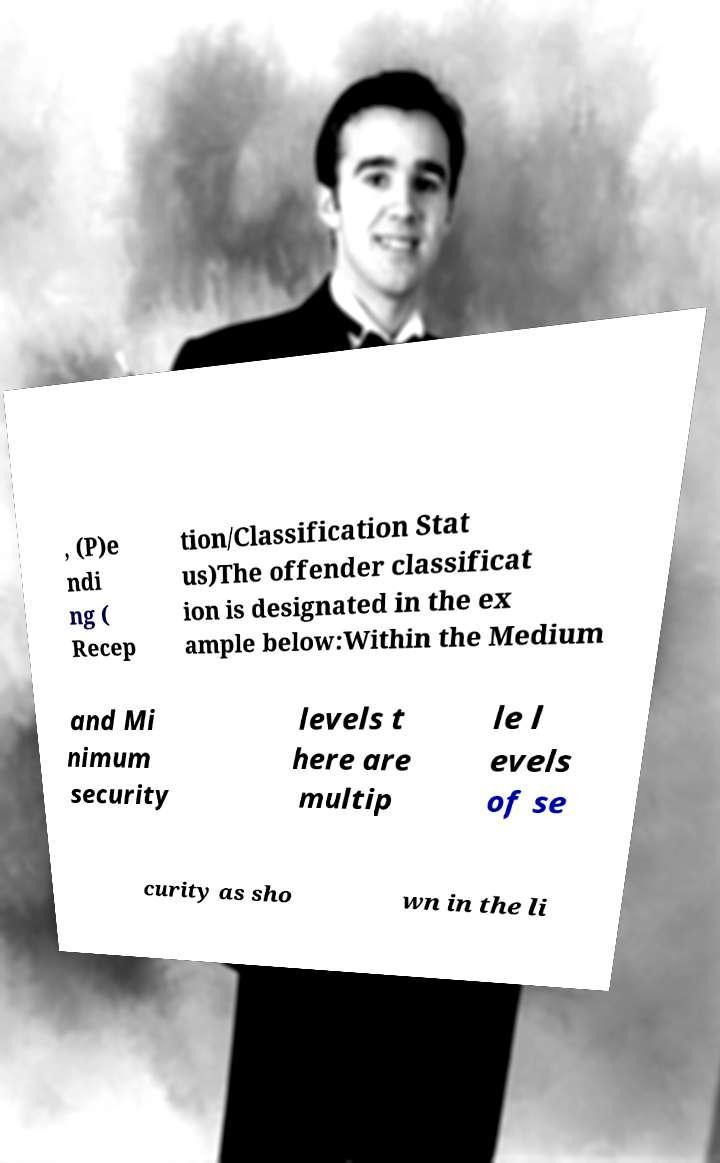What messages or text are displayed in this image? I need them in a readable, typed format. , (P)e ndi ng ( Recep tion/Classification Stat us)The offender classificat ion is designated in the ex ample below:Within the Medium and Mi nimum security levels t here are multip le l evels of se curity as sho wn in the li 